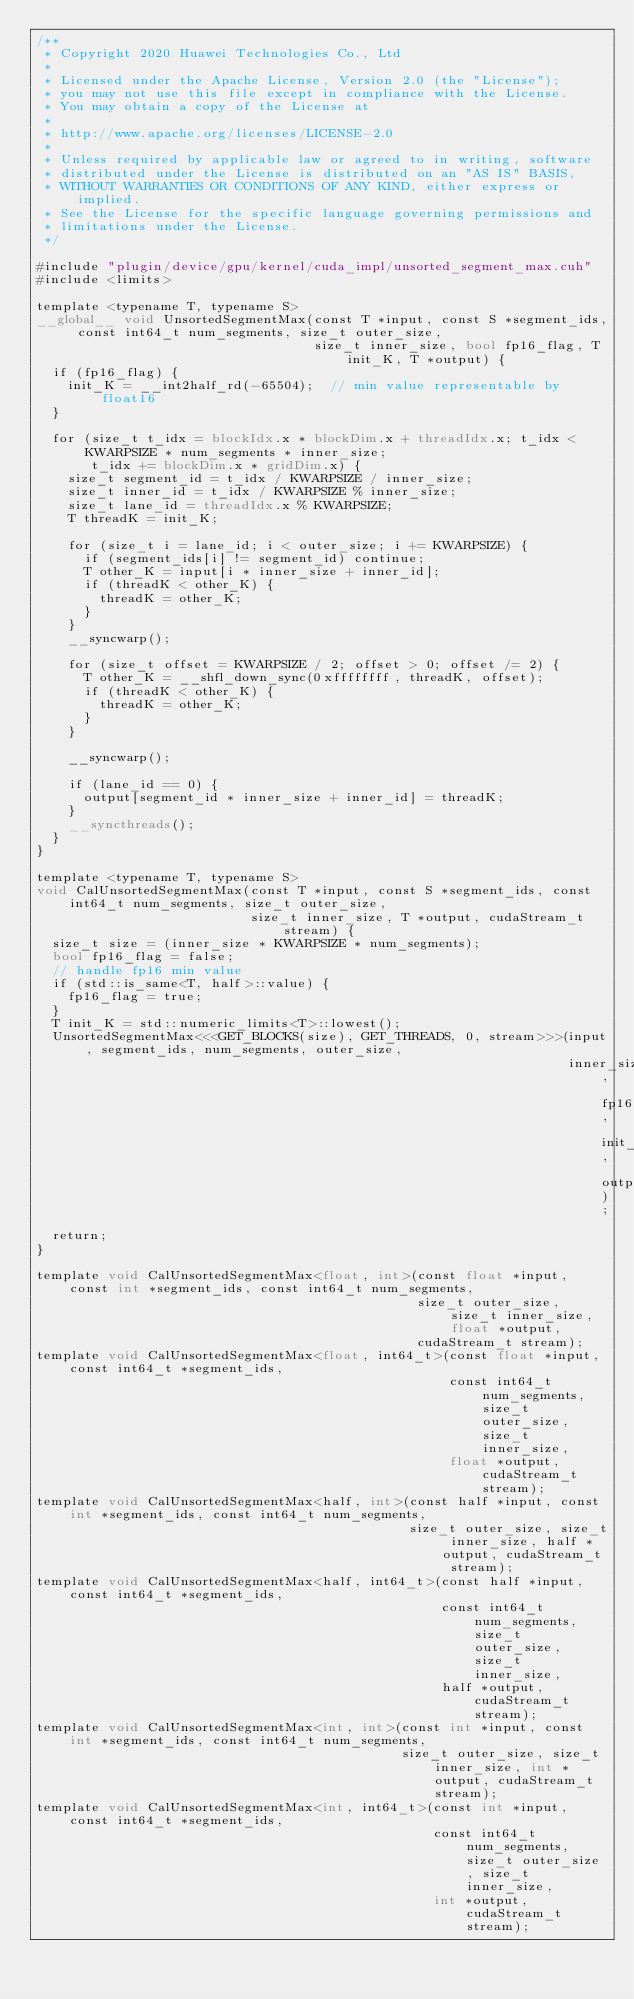Convert code to text. <code><loc_0><loc_0><loc_500><loc_500><_Cuda_>/**
 * Copyright 2020 Huawei Technologies Co., Ltd
 *
 * Licensed under the Apache License, Version 2.0 (the "License");
 * you may not use this file except in compliance with the License.
 * You may obtain a copy of the License at
 *
 * http://www.apache.org/licenses/LICENSE-2.0
 *
 * Unless required by applicable law or agreed to in writing, software
 * distributed under the License is distributed on an "AS IS" BASIS,
 * WITHOUT WARRANTIES OR CONDITIONS OF ANY KIND, either express or implied.
 * See the License for the specific language governing permissions and
 * limitations under the License.
 */

#include "plugin/device/gpu/kernel/cuda_impl/unsorted_segment_max.cuh"
#include <limits>

template <typename T, typename S>
__global__ void UnsortedSegmentMax(const T *input, const S *segment_ids, const int64_t num_segments, size_t outer_size,
                                   size_t inner_size, bool fp16_flag, T init_K, T *output) {
  if (fp16_flag) {
    init_K = __int2half_rd(-65504);  // min value representable by float16
  }

  for (size_t t_idx = blockIdx.x * blockDim.x + threadIdx.x; t_idx < KWARPSIZE * num_segments * inner_size;
       t_idx += blockDim.x * gridDim.x) {
    size_t segment_id = t_idx / KWARPSIZE / inner_size;
    size_t inner_id = t_idx / KWARPSIZE % inner_size;
    size_t lane_id = threadIdx.x % KWARPSIZE;
    T threadK = init_K;

    for (size_t i = lane_id; i < outer_size; i += KWARPSIZE) {
      if (segment_ids[i] != segment_id) continue;
      T other_K = input[i * inner_size + inner_id];
      if (threadK < other_K) {
        threadK = other_K;
      }
    }
    __syncwarp();

    for (size_t offset = KWARPSIZE / 2; offset > 0; offset /= 2) {
      T other_K = __shfl_down_sync(0xffffffff, threadK, offset);
      if (threadK < other_K) {
        threadK = other_K;
      }
    }

    __syncwarp();

    if (lane_id == 0) {
      output[segment_id * inner_size + inner_id] = threadK;
    }
    __syncthreads();
  }
}

template <typename T, typename S>
void CalUnsortedSegmentMax(const T *input, const S *segment_ids, const int64_t num_segments, size_t outer_size,
                           size_t inner_size, T *output, cudaStream_t stream) {
  size_t size = (inner_size * KWARPSIZE * num_segments);
  bool fp16_flag = false;
  // handle fp16 min value
  if (std::is_same<T, half>::value) {
    fp16_flag = true;
  }
  T init_K = std::numeric_limits<T>::lowest();
  UnsortedSegmentMax<<<GET_BLOCKS(size), GET_THREADS, 0, stream>>>(input, segment_ids, num_segments, outer_size,
                                                                   inner_size, fp16_flag, init_K, output);
  return;
}

template void CalUnsortedSegmentMax<float, int>(const float *input, const int *segment_ids, const int64_t num_segments,
                                                size_t outer_size, size_t inner_size, float *output,
                                                cudaStream_t stream);
template void CalUnsortedSegmentMax<float, int64_t>(const float *input, const int64_t *segment_ids,
                                                    const int64_t num_segments, size_t outer_size, size_t inner_size,
                                                    float *output, cudaStream_t stream);
template void CalUnsortedSegmentMax<half, int>(const half *input, const int *segment_ids, const int64_t num_segments,
                                               size_t outer_size, size_t inner_size, half *output, cudaStream_t stream);
template void CalUnsortedSegmentMax<half, int64_t>(const half *input, const int64_t *segment_ids,
                                                   const int64_t num_segments, size_t outer_size, size_t inner_size,
                                                   half *output, cudaStream_t stream);
template void CalUnsortedSegmentMax<int, int>(const int *input, const int *segment_ids, const int64_t num_segments,
                                              size_t outer_size, size_t inner_size, int *output, cudaStream_t stream);
template void CalUnsortedSegmentMax<int, int64_t>(const int *input, const int64_t *segment_ids,
                                                  const int64_t num_segments, size_t outer_size, size_t inner_size,
                                                  int *output, cudaStream_t stream);
</code> 